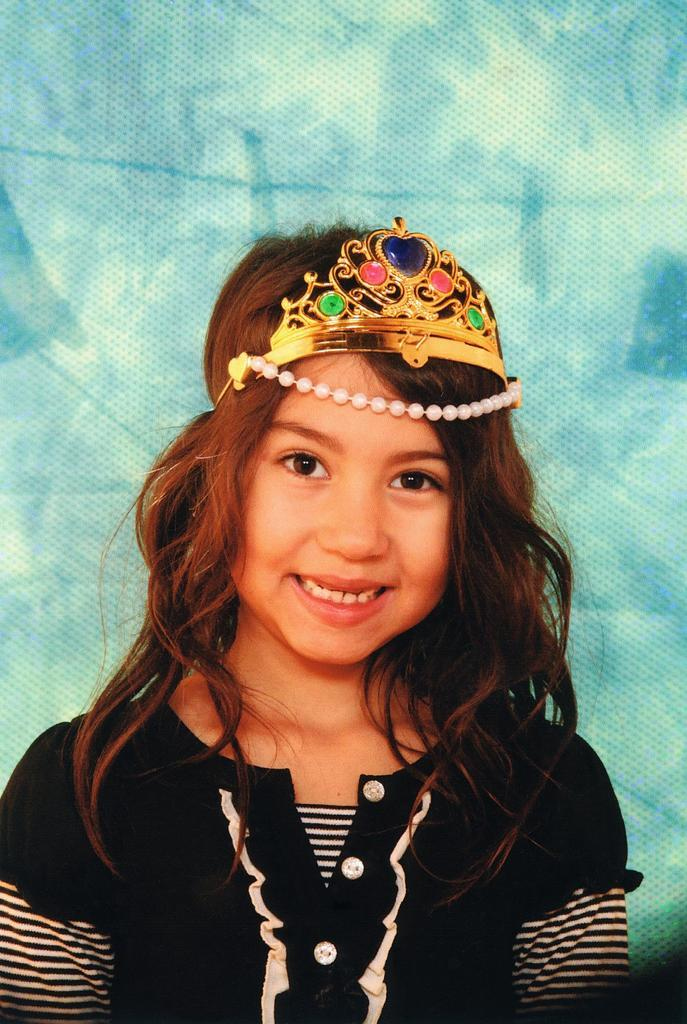Who is the main subject in the image? There is a girl in the image. What is the girl wearing on her head? The girl is wearing a crown. What expression does the girl have on her face? The girl is smiling. What color is the background of the image? The background of the image is blue. What type of tree is growing in the background of the image? There is no tree present in the background of the image; it is blue. 